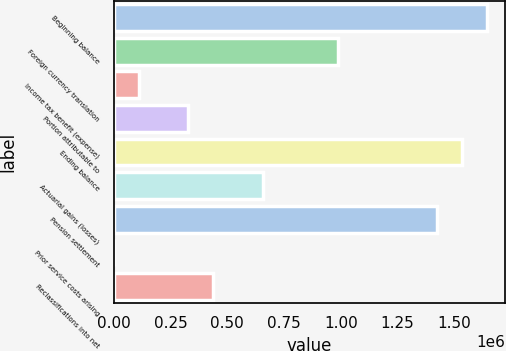<chart> <loc_0><loc_0><loc_500><loc_500><bar_chart><fcel>Beginning balance<fcel>Foreign currency translation<fcel>Income tax benefit (expense)<fcel>Portion attributable to<fcel>Ending balance<fcel>Actuarial gains (losses)<fcel>Pension settlement<fcel>Prior service costs arising<fcel>Reclassifications into net<nl><fcel>1.64175e+06<fcel>985390<fcel>110241<fcel>329028<fcel>1.53236e+06<fcel>657209<fcel>1.42297e+06<fcel>847<fcel>438422<nl></chart> 